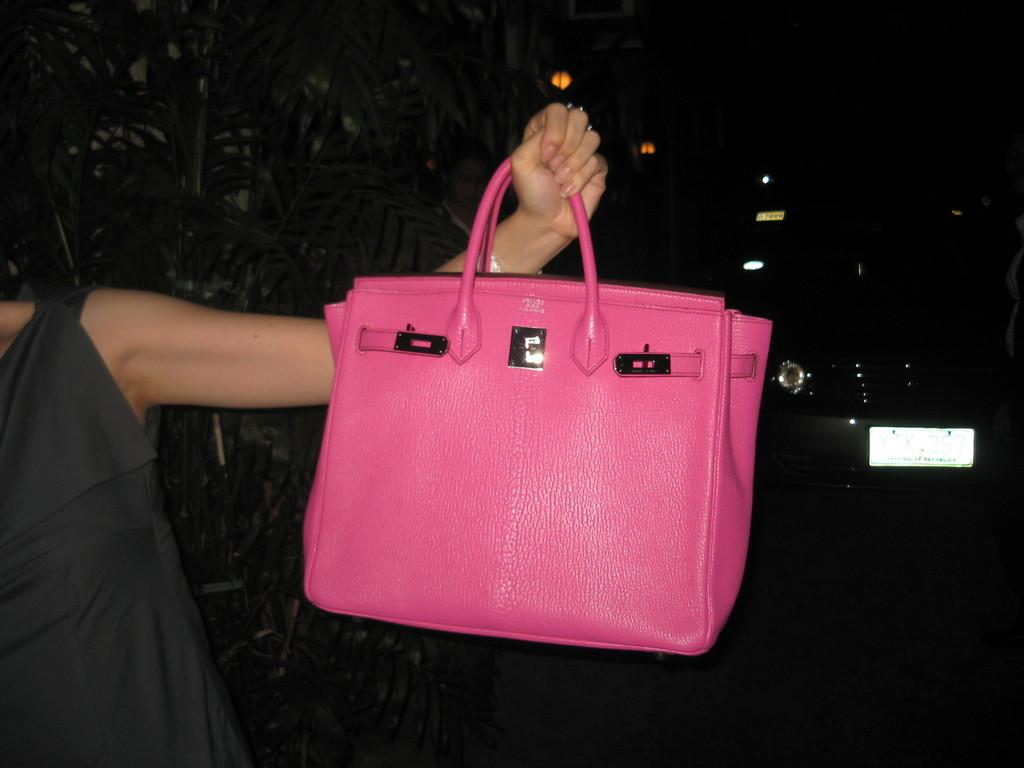What color is the handbag in the picture? The handbag in the picture is pink. Who is holding the pink handbag? A woman is holding the pink handbag. What can be seen in the image besides the handbag and the woman? There are plants in the image. What is the woman doing near the plants? The woman is standing near the plants. What else is present in the image? There is a vehicle in the image. What type of berry is growing on the plants in the image? There is no berry growing on the plants in the image; only the plants themselves are visible. 